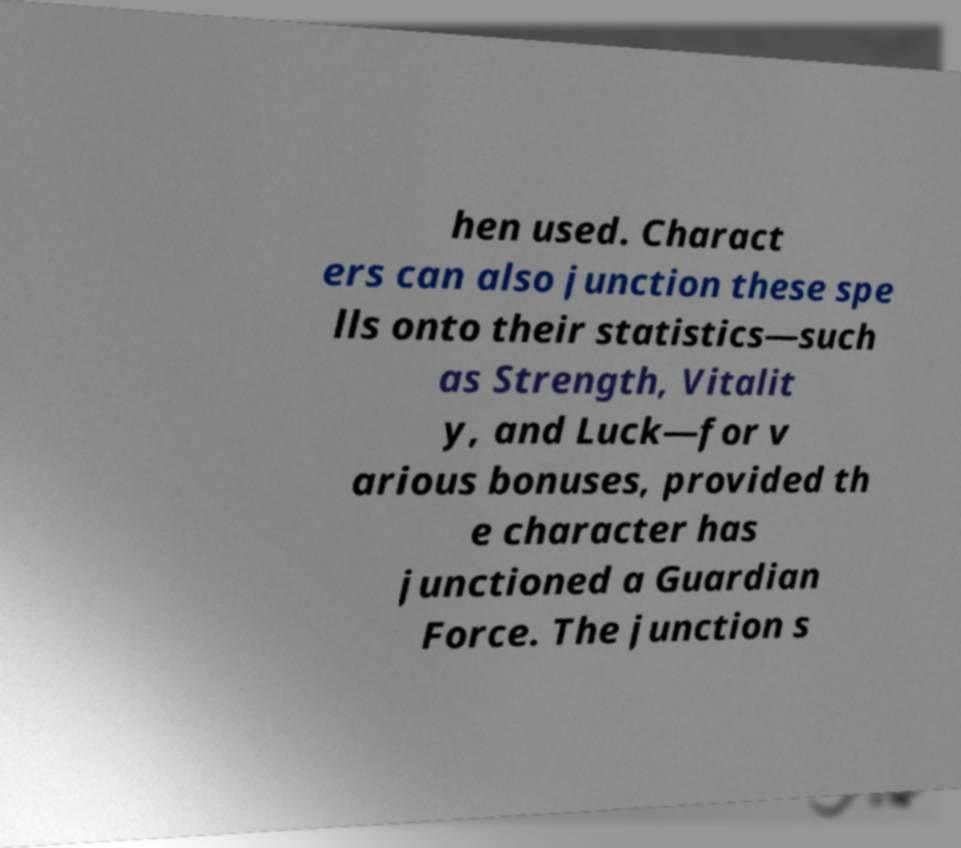Can you accurately transcribe the text from the provided image for me? hen used. Charact ers can also junction these spe lls onto their statistics—such as Strength, Vitalit y, and Luck—for v arious bonuses, provided th e character has junctioned a Guardian Force. The junction s 